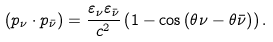<formula> <loc_0><loc_0><loc_500><loc_500>( p _ { \nu } \cdot p _ { \bar { \nu } } ) = \frac { \varepsilon _ { \nu } \varepsilon _ { \bar { \nu } } } { c ^ { 2 } } \left ( 1 - \cos { ( \theta { \nu } - \theta { \bar { \nu } } ) } \right ) .</formula> 